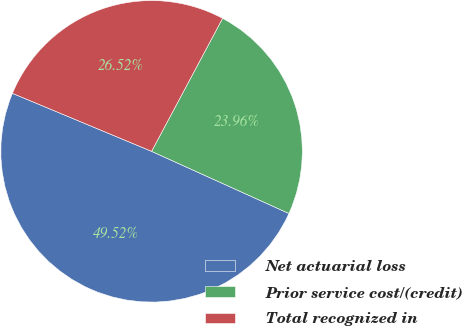<chart> <loc_0><loc_0><loc_500><loc_500><pie_chart><fcel>Net actuarial loss<fcel>Prior service cost/(credit)<fcel>Total recognized in<nl><fcel>49.52%<fcel>23.96%<fcel>26.52%<nl></chart> 